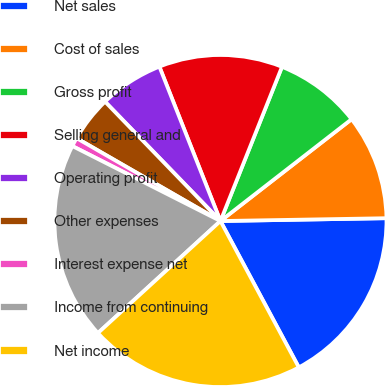Convert chart. <chart><loc_0><loc_0><loc_500><loc_500><pie_chart><fcel>Net sales<fcel>Cost of sales<fcel>Gross profit<fcel>Selling general and<fcel>Operating profit<fcel>Other expenses<fcel>Interest expense net<fcel>Income from continuing<fcel>Net income<nl><fcel>17.45%<fcel>10.24%<fcel>8.45%<fcel>12.04%<fcel>6.24%<fcel>4.45%<fcel>0.86%<fcel>19.25%<fcel>21.04%<nl></chart> 